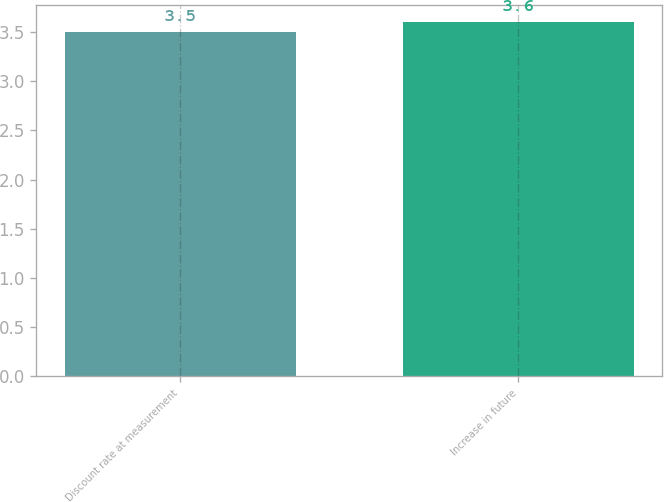Convert chart to OTSL. <chart><loc_0><loc_0><loc_500><loc_500><bar_chart><fcel>Discount rate at measurement<fcel>Increase in future<nl><fcel>3.5<fcel>3.6<nl></chart> 